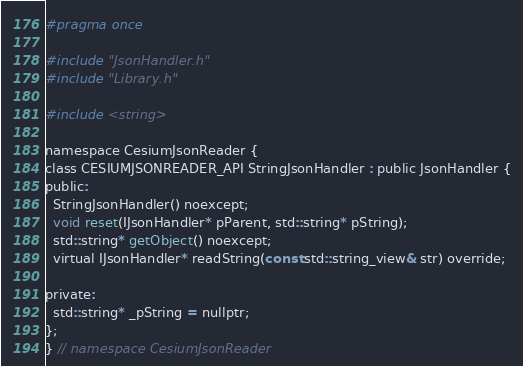<code> <loc_0><loc_0><loc_500><loc_500><_C_>#pragma once

#include "JsonHandler.h"
#include "Library.h"

#include <string>

namespace CesiumJsonReader {
class CESIUMJSONREADER_API StringJsonHandler : public JsonHandler {
public:
  StringJsonHandler() noexcept;
  void reset(IJsonHandler* pParent, std::string* pString);
  std::string* getObject() noexcept;
  virtual IJsonHandler* readString(const std::string_view& str) override;

private:
  std::string* _pString = nullptr;
};
} // namespace CesiumJsonReader
</code> 